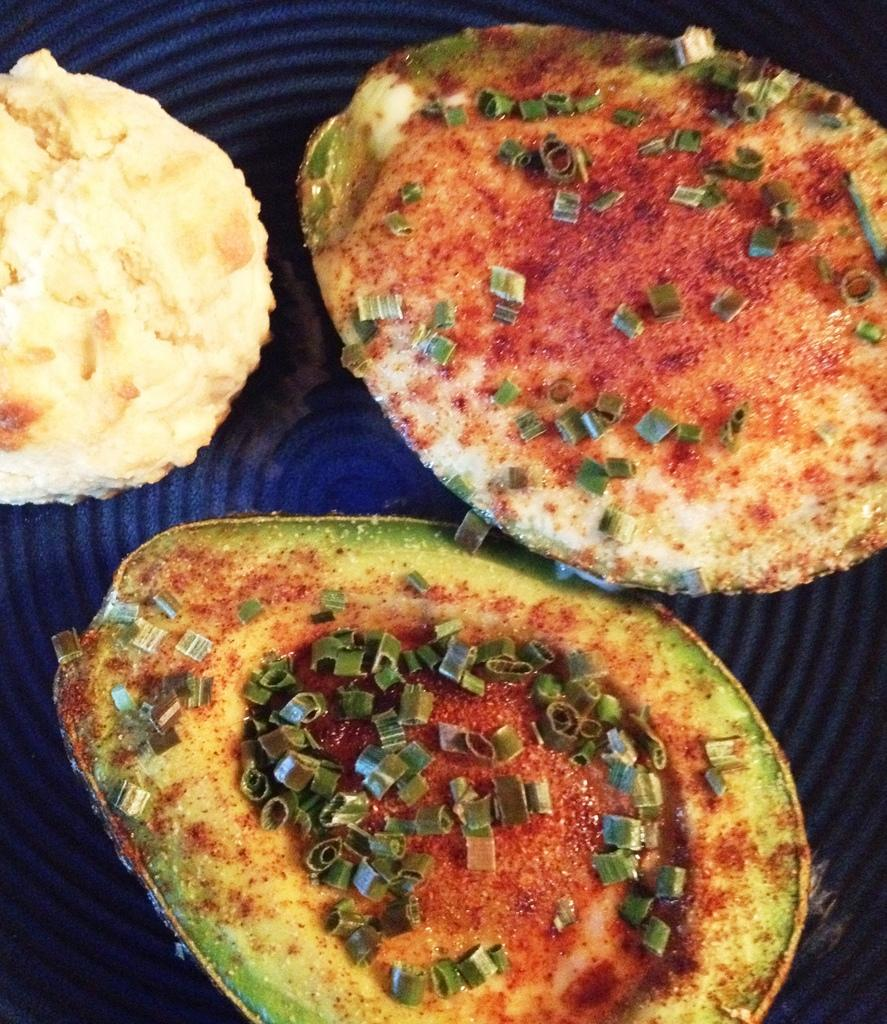What type of food item can be seen in the image? There is a cookie and a kiwi in the image. What is the cookie placed on in the image? There is a food item on a plate in the image. Can you describe the other fruit in the image? The other fruit is a kiwi. Where might the image have been taken? The image may have been taken in a room, but this cannot be confirmed with certainty based on the provided information. What type of garden can be seen in the image? There is no garden present in the image; it features a cookie, a kiwi, and a food item on a plate. 